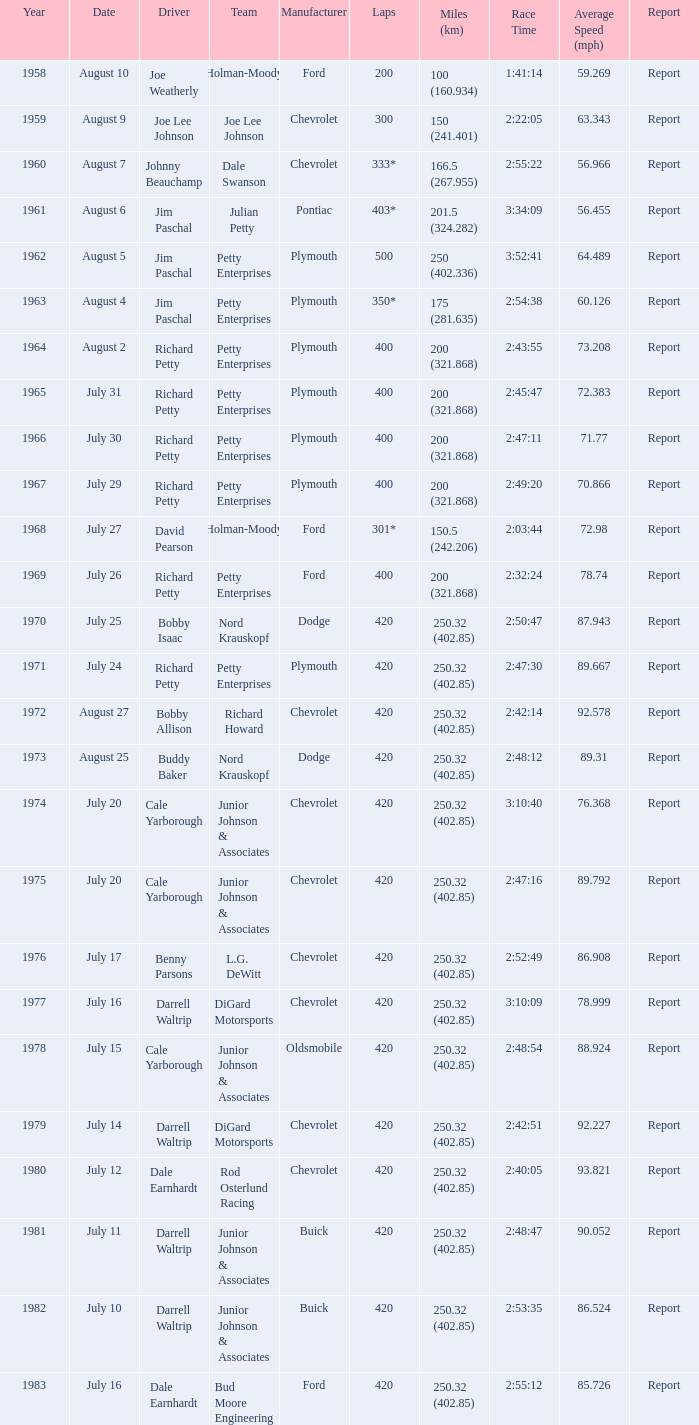In the race with a winning time of 2:47:11, how many miles were traveled? 200 (321.868). 